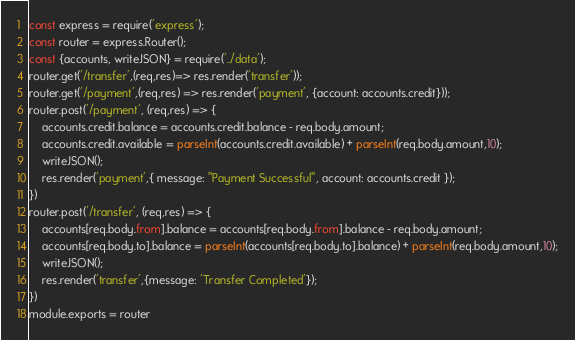Convert code to text. <code><loc_0><loc_0><loc_500><loc_500><_JavaScript_>const express = require('express');
const router = express.Router();
const {accounts, writeJSON} = require('../data');
router.get('/transfer',(req,res)=> res.render('transfer'));
router.get('/payment',(req,res) => res.render('payment', {account: accounts.credit}));
router.post('/payment', (req,res) => { 
    accounts.credit.balance = accounts.credit.balance - req.body.amount;
    accounts.credit.available = parseInt(accounts.credit.available) + parseInt(req.body.amount,10);
    writeJSON();
    res.render('payment',{ message: "Payment Successful", account: accounts.credit });
})
router.post('/transfer', (req,res) => { 
    accounts[req.body.from].balance = accounts[req.body.from].balance - req.body.amount;
    accounts[req.body.to].balance = parseInt(accounts[req.body.to].balance) + parseInt(req.body.amount,10);
    writeJSON();
    res.render('transfer',{message: 'Transfer Completed'});
})
module.exports = router</code> 